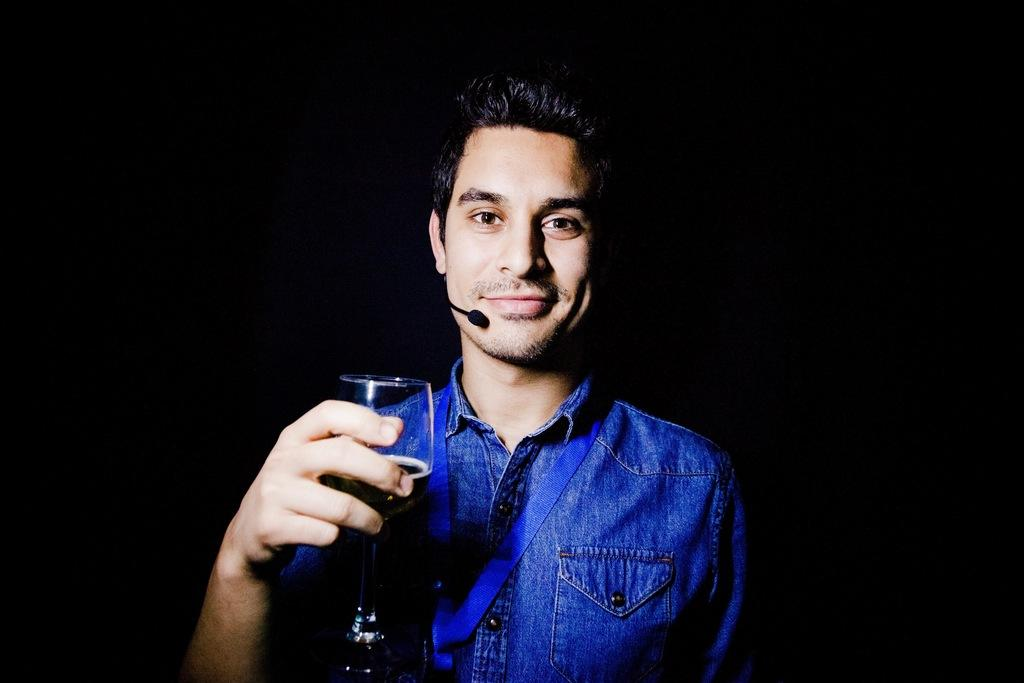Who is present in the image? There is a man in the image. What is the man wearing? The man is wearing a blue shirt. What object is the man holding? The man is holding a bottle. What other object can be seen in the image? There is a microphone (mic) in the image. Can you describe the sense of smell in the image? There is no specific reference to the sense of smell in the image, so it cannot be described. 